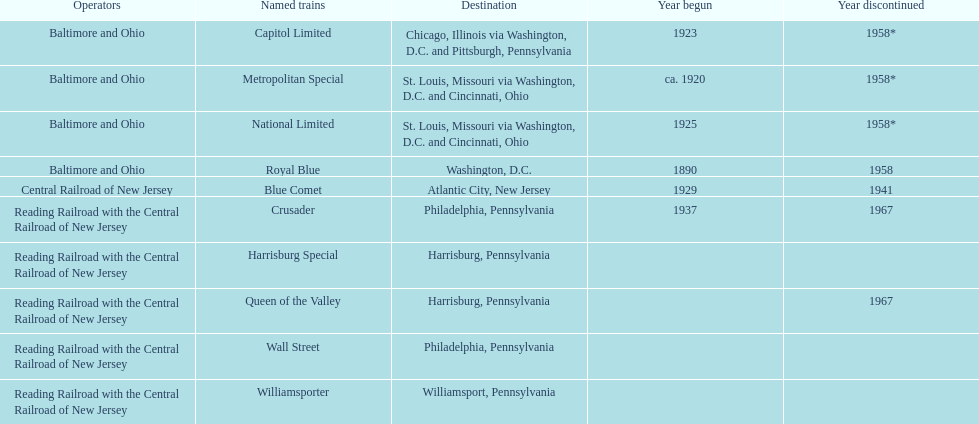What is the total number of year begun? 6. 